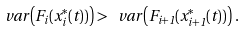<formula> <loc_0><loc_0><loc_500><loc_500>\ v a r \left ( F _ { i } ( x _ { i } ^ { * } ( t ) ) \right ) > \ v a r \left ( F _ { i + 1 } ( x _ { i + 1 } ^ { * } ( t ) ) \right ) \, .</formula> 